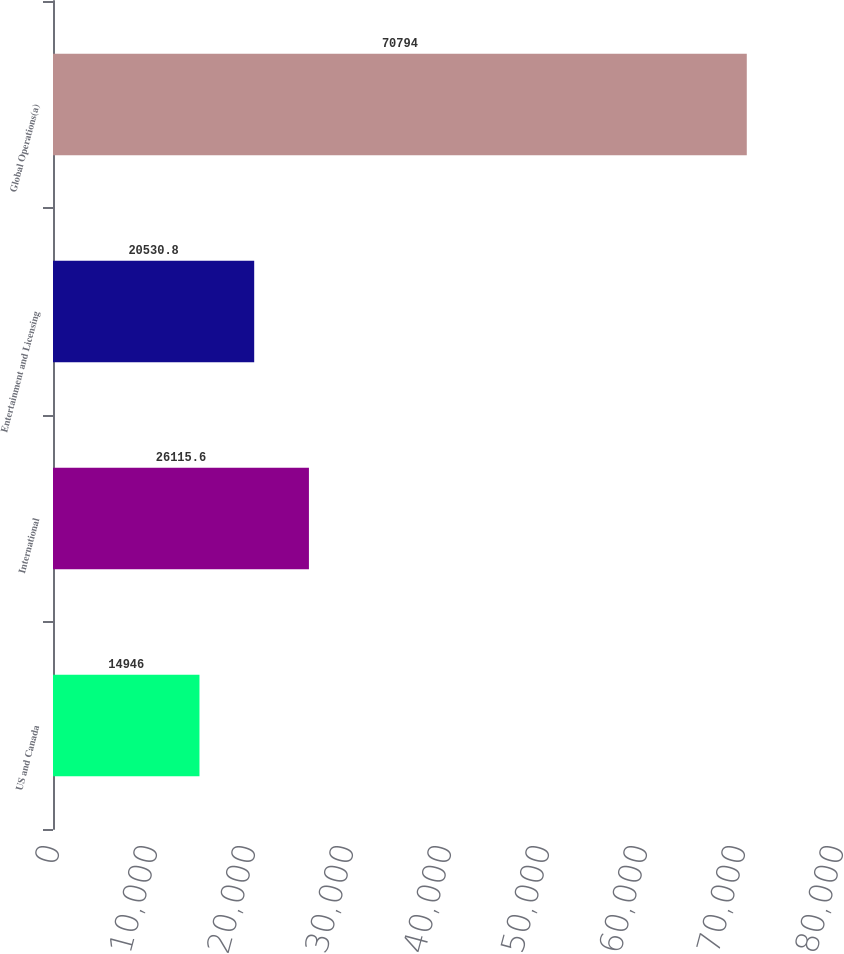Convert chart to OTSL. <chart><loc_0><loc_0><loc_500><loc_500><bar_chart><fcel>US and Canada<fcel>International<fcel>Entertainment and Licensing<fcel>Global Operations(a)<nl><fcel>14946<fcel>26115.6<fcel>20530.8<fcel>70794<nl></chart> 